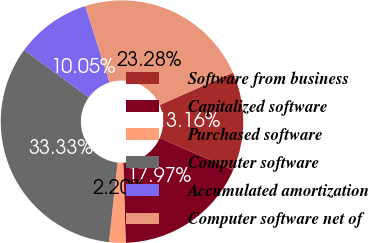<chart> <loc_0><loc_0><loc_500><loc_500><pie_chart><fcel>Software from business<fcel>Capitalized software<fcel>Purchased software<fcel>Computer software<fcel>Accumulated amortization<fcel>Computer software net of<nl><fcel>13.16%<fcel>17.97%<fcel>2.2%<fcel>33.33%<fcel>10.05%<fcel>23.28%<nl></chart> 